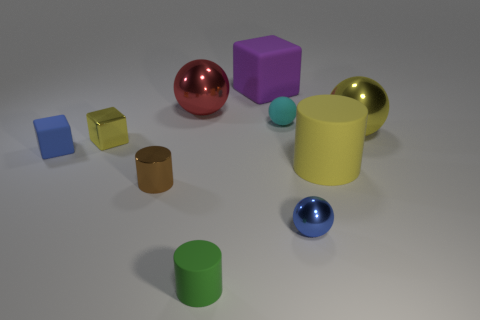Can you describe the materials of the objects in the image? Certainly! The objects exhibit a variety of finishes: the cubes and spheres have shiny, reflective surfaces suggesting a metallic or polished texture, while others like the matte cube and ball have a more diffused look that absorbs light, indicating a non-reflective material. 